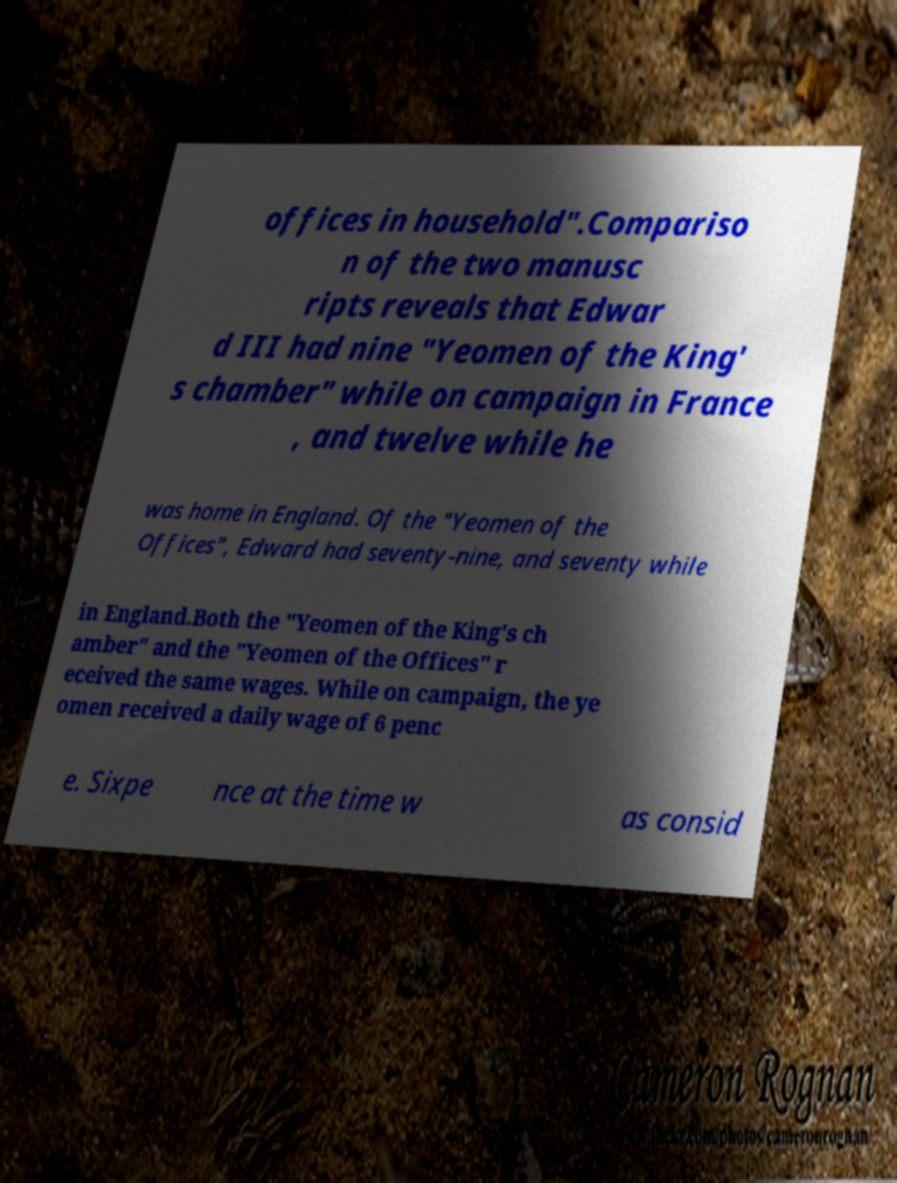Could you assist in decoding the text presented in this image and type it out clearly? offices in household".Compariso n of the two manusc ripts reveals that Edwar d III had nine "Yeomen of the King' s chamber" while on campaign in France , and twelve while he was home in England. Of the "Yeomen of the Offices", Edward had seventy-nine, and seventy while in England.Both the "Yeomen of the King's ch amber" and the "Yeomen of the Offices" r eceived the same wages. While on campaign, the ye omen received a daily wage of 6 penc e. Sixpe nce at the time w as consid 